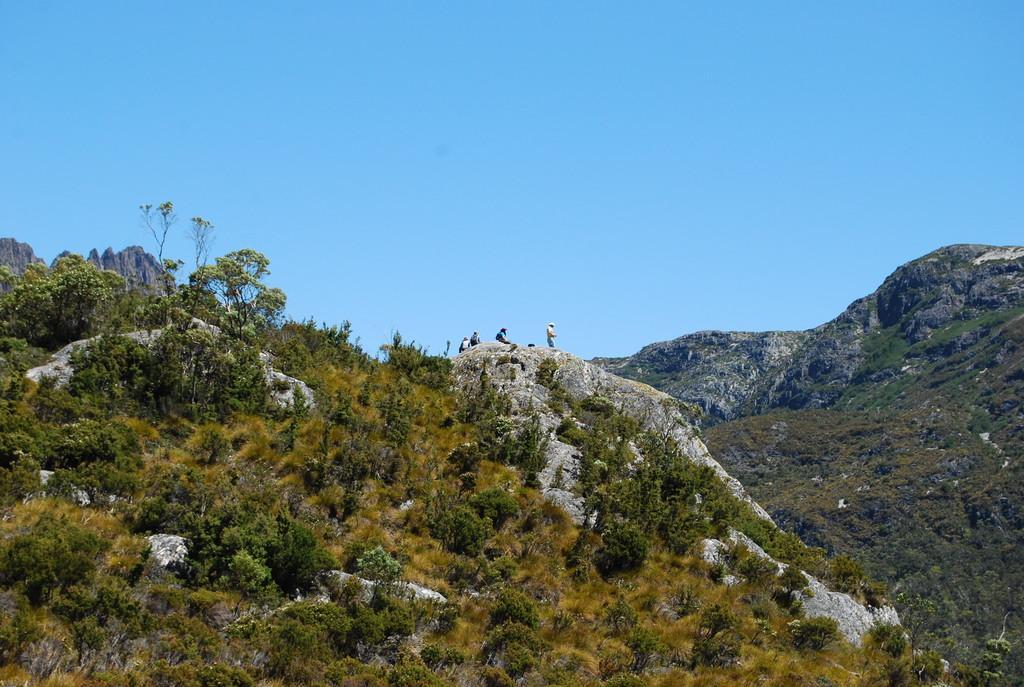In one or two sentences, can you explain what this image depicts? In this image I can see few mountains, few trees and few people are standing. The sky is in blue color. 